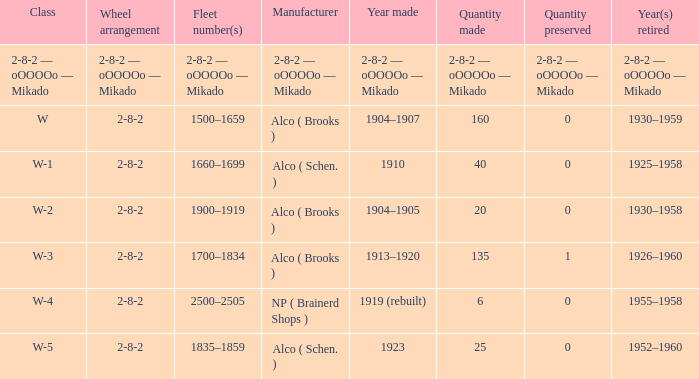What is the quantity preserved to the locomotive with a quantity made of 6? 0.0. Write the full table. {'header': ['Class', 'Wheel arrangement', 'Fleet number(s)', 'Manufacturer', 'Year made', 'Quantity made', 'Quantity preserved', 'Year(s) retired'], 'rows': [['2-8-2 — oOOOOo — Mikado', '2-8-2 — oOOOOo — Mikado', '2-8-2 — oOOOOo — Mikado', '2-8-2 — oOOOOo — Mikado', '2-8-2 — oOOOOo — Mikado', '2-8-2 — oOOOOo — Mikado', '2-8-2 — oOOOOo — Mikado', '2-8-2 — oOOOOo — Mikado'], ['W', '2-8-2', '1500–1659', 'Alco ( Brooks )', '1904–1907', '160', '0', '1930–1959'], ['W-1', '2-8-2', '1660–1699', 'Alco ( Schen. )', '1910', '40', '0', '1925–1958'], ['W-2', '2-8-2', '1900–1919', 'Alco ( Brooks )', '1904–1905', '20', '0', '1930–1958'], ['W-3', '2-8-2', '1700–1834', 'Alco ( Brooks )', '1913–1920', '135', '1', '1926–1960'], ['W-4', '2-8-2', '2500–2505', 'NP ( Brainerd Shops )', '1919 (rebuilt)', '6', '0', '1955–1958'], ['W-5', '2-8-2', '1835–1859', 'Alco ( Schen. )', '1923', '25', '0', '1952–1960']]} 